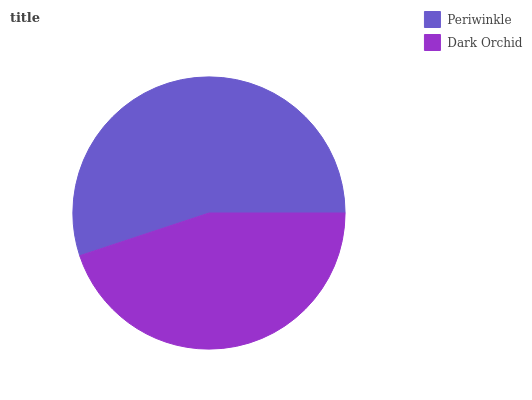Is Dark Orchid the minimum?
Answer yes or no. Yes. Is Periwinkle the maximum?
Answer yes or no. Yes. Is Dark Orchid the maximum?
Answer yes or no. No. Is Periwinkle greater than Dark Orchid?
Answer yes or no. Yes. Is Dark Orchid less than Periwinkle?
Answer yes or no. Yes. Is Dark Orchid greater than Periwinkle?
Answer yes or no. No. Is Periwinkle less than Dark Orchid?
Answer yes or no. No. Is Periwinkle the high median?
Answer yes or no. Yes. Is Dark Orchid the low median?
Answer yes or no. Yes. Is Dark Orchid the high median?
Answer yes or no. No. Is Periwinkle the low median?
Answer yes or no. No. 